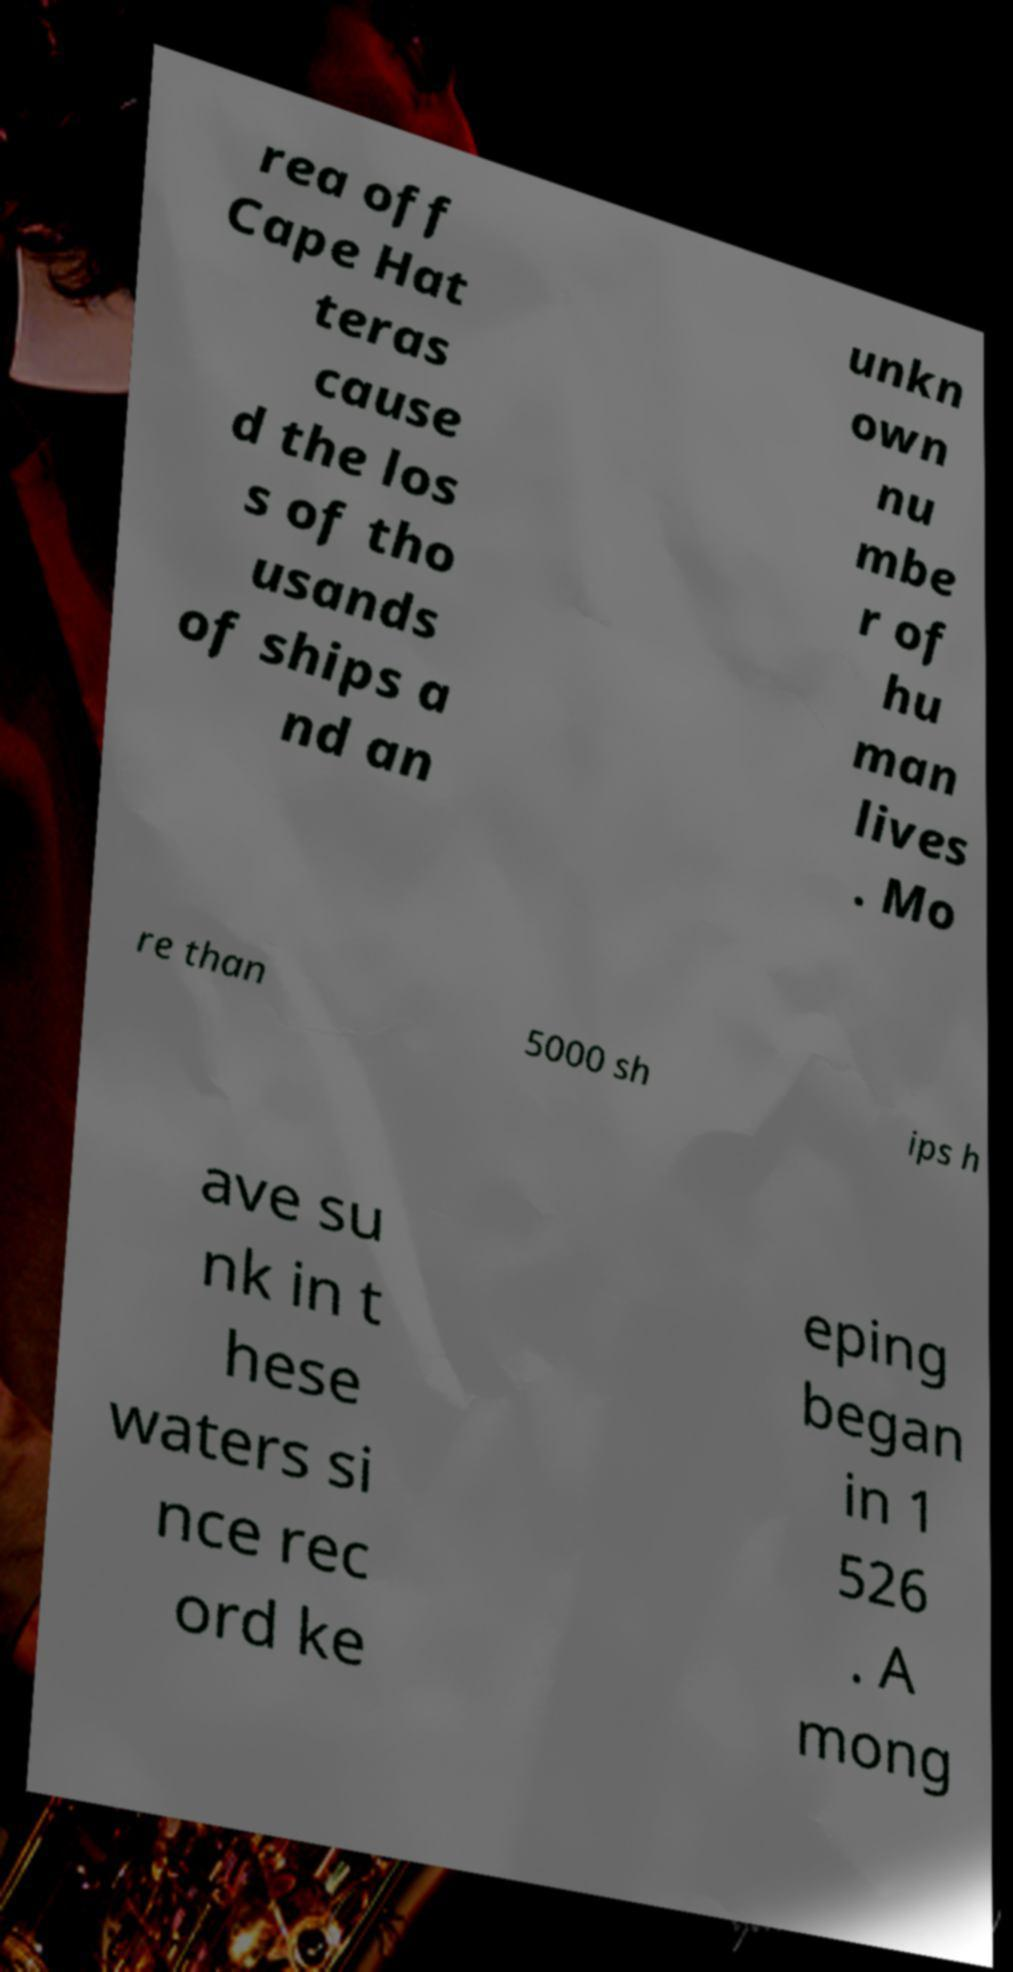There's text embedded in this image that I need extracted. Can you transcribe it verbatim? rea off Cape Hat teras cause d the los s of tho usands of ships a nd an unkn own nu mbe r of hu man lives . Mo re than 5000 sh ips h ave su nk in t hese waters si nce rec ord ke eping began in 1 526 . A mong 